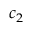<formula> <loc_0><loc_0><loc_500><loc_500>c _ { 2 }</formula> 